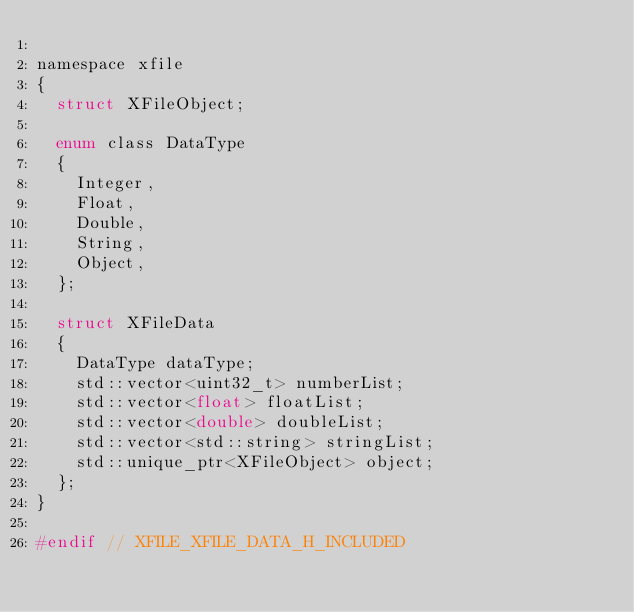<code> <loc_0><loc_0><loc_500><loc_500><_C_>
namespace xfile
{
	struct XFileObject;

	enum class DataType
	{
		Integer,
		Float,
		Double,
		String,
		Object,
	};

	struct XFileData
	{
		DataType dataType;
		std::vector<uint32_t> numberList;
		std::vector<float> floatList;
		std::vector<double> doubleList;
		std::vector<std::string> stringList;
		std::unique_ptr<XFileObject> object;
	};
}

#endif // XFILE_XFILE_DATA_H_INCLUDED
</code> 